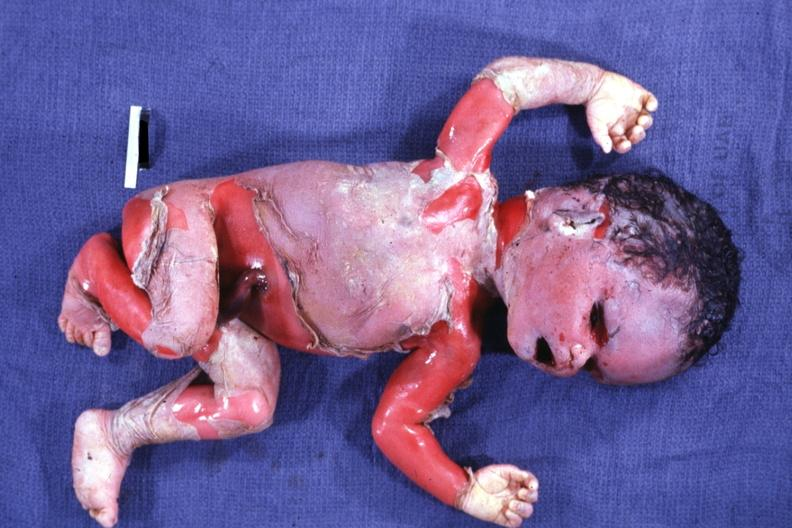s macerated stillborn present?
Answer the question using a single word or phrase. Yes 